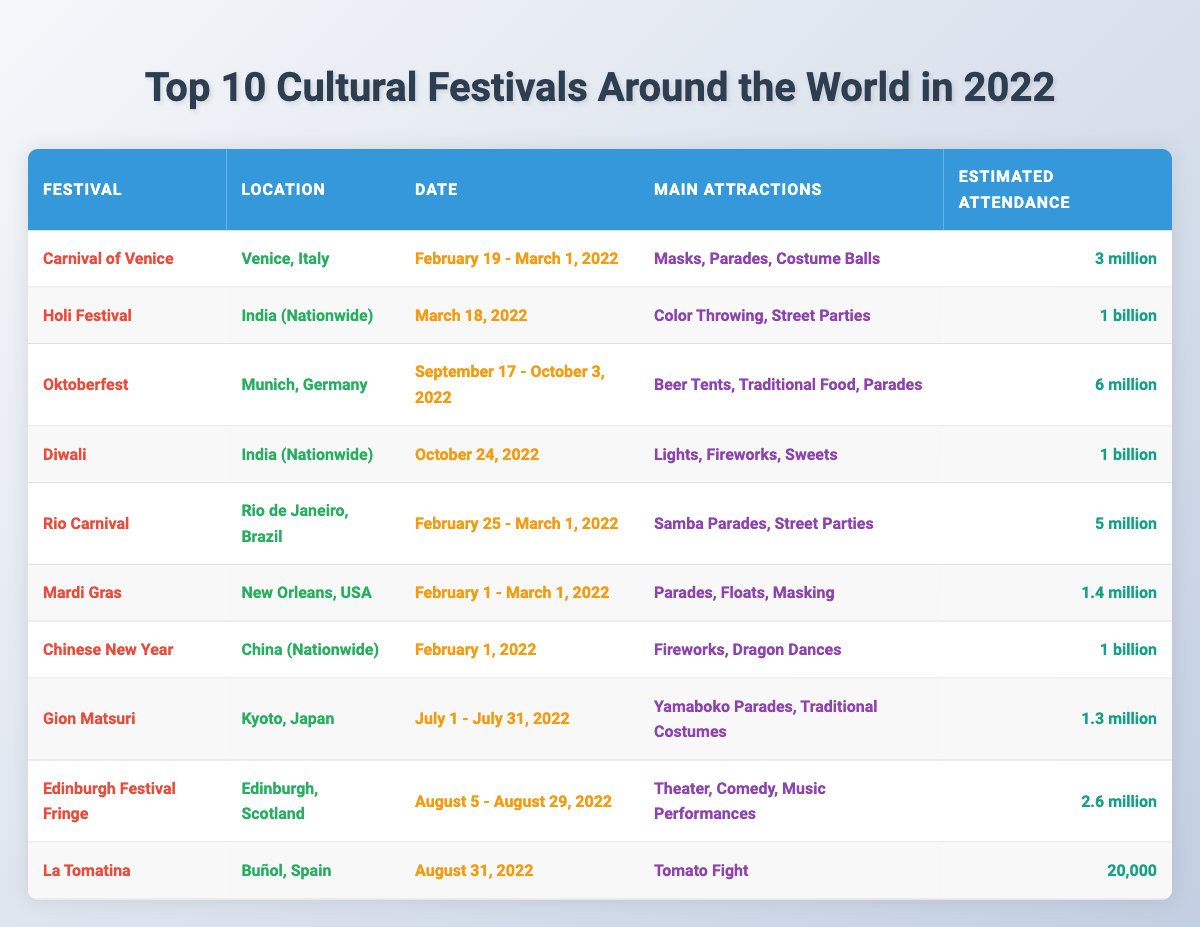What is the location of the Carnival of Venice? The table specifies that the Carnival of Venice is located in Venice, Italy.
Answer: Venice, Italy How many estimated attendees are there for Diwali? According to the table, Diwali has an estimated attendance of 1 billion people.
Answer: 1 billion What are the main attractions of Oktoberfest? The table lists the main attractions of Oktoberfest as beer tents, traditional food, and parades.
Answer: Beer tents, traditional food, parades Which festival has the highest estimated attendance? By reviewing the attendance figures, both Diwali and the Holi Festival have the highest estimated attendance at 1 billion each.
Answer: Diwali and Holi Festival Is the Edinburgh Festival Fringe held in August? The table shows that the Edinburgh Festival Fringe takes place from August 5 to August 29, 2022, confirming it is in August.
Answer: Yes What is the date range for the Rio Carnival? From the table, the Rio Carnival occurs from February 25 to March 1, 2022.
Answer: February 25 - March 1, 2022 How many festivals listed are celebrated in India? The table indicates that Holi and Diwali are celebrated in India, making a total of 2 festivals.
Answer: 2 What is the difference in estimated attendance between the Carnival of Venice and the Oktoberfest? The Carnival of Venice has an estimated attendance of 3 million and Oktoberfest has 6 million. Subtracting the former from the latter: 6 million - 3 million = 3 million.
Answer: 3 million How many festivals have an estimated attendance of over 5 million? The festivals with over 5 million attendees are Holi Festival, Diwali, and Oktoberfest, which totals 3 festivals.
Answer: 3 Which festival in Spain is listed in the table? The table identifies La Tomatina as the festival held in Spain.
Answer: La Tomatina What is the significance of the Gion Matsuri festival in Japan? The table highlights the Gion Matsuri for its yamaboko parades and traditional costumes.
Answer: Yamaboko parades, traditional costumes What months do the majority of these festivals occur? Analyzing the dates, the majority of the festivals occur in February (3 festivals), followed by October (1 festival), and August (2 festivals), indicating February is the peak month.
Answer: February Which festival occurs on February 1st? The table indicates that the Chinese New Year festival is held on February 1, 2022.
Answer: Chinese New Year What is the estimated attendance for La Tomatina? According to the table, La Tomatina’s estimated attendance is 20,000 people.
Answer: 20,000 What are the main attractions of the Holi Festival? The table states that the main attractions of the Holi Festival are color throwing and street parties.
Answer: Color throwing, street parties Which festival has the least estimated attendance? By evaluating the attendance figures, La Tomatina has the least estimated attendance at 20,000.
Answer: La Tomatina How many countries host one of the festivals mentioned? The table reveals festivals hosted in five countries: Italy, India, Germany, Brazil, the USA, China, and Japan. Therefore, there are a total of 7 countries.
Answer: 7 